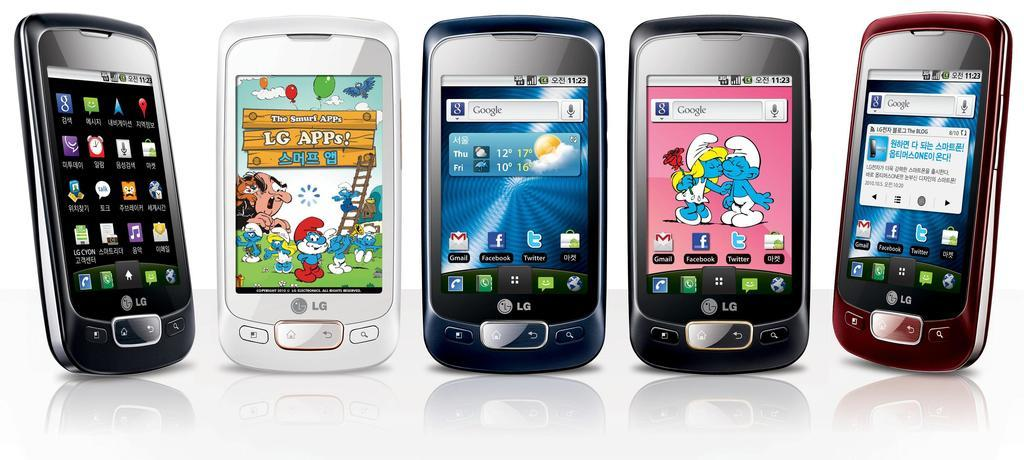<image>
Offer a succinct explanation of the picture presented. Five phones on display all made by the company LG. 